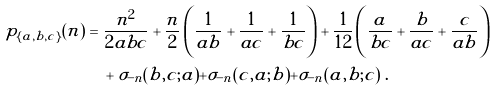<formula> <loc_0><loc_0><loc_500><loc_500>p _ { \{ a , b , c \} } ( n ) & = \frac { n ^ { 2 } } { 2 a b c } + \frac { n } { 2 } \left ( \frac { 1 } { a b } + \frac { 1 } { a c } + \frac { 1 } { b c } \right ) + \frac { 1 } { 1 2 } \left ( \frac { a } { b c } + \frac { b } { a c } + \frac { c } { a b } \right ) \\ & \quad + \sigma _ { - n } ( b , c ; a ) + \sigma _ { - n } ( c , a ; b ) + \sigma _ { - n } ( a , b ; c ) \ .</formula> 